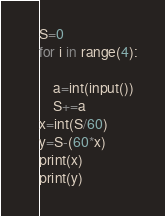<code> <loc_0><loc_0><loc_500><loc_500><_Python_>S=0
for i in range(4):
    
    a=int(input())
    S+=a
x=int(S/60)
y=S-(60*x)
print(x)
print(y)
</code> 